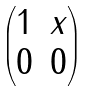Convert formula to latex. <formula><loc_0><loc_0><loc_500><loc_500>\begin{pmatrix} 1 & x \\ 0 & 0 \end{pmatrix}</formula> 